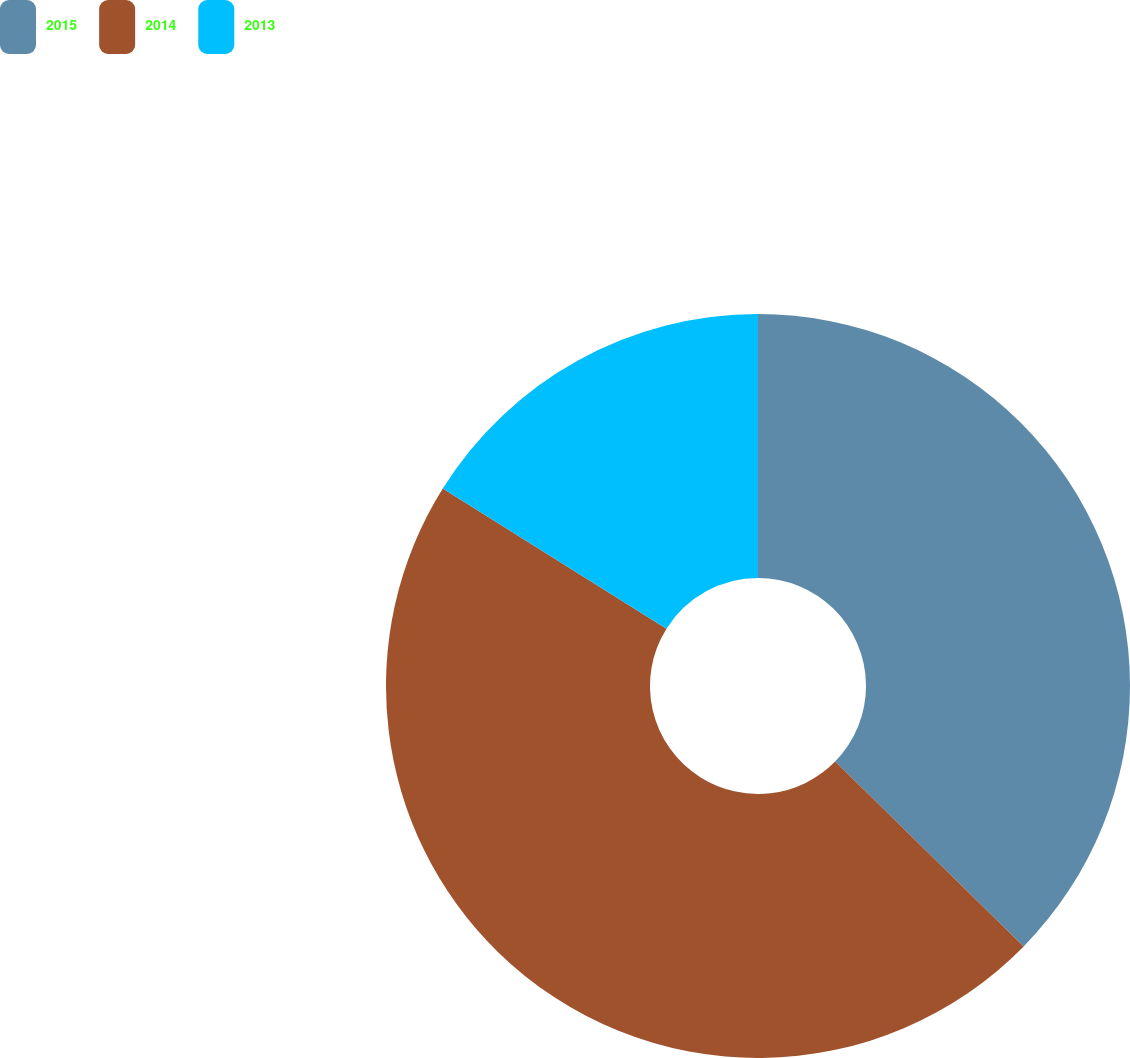Convert chart to OTSL. <chart><loc_0><loc_0><loc_500><loc_500><pie_chart><fcel>2015<fcel>2014<fcel>2013<nl><fcel>37.34%<fcel>46.57%<fcel>16.09%<nl></chart> 